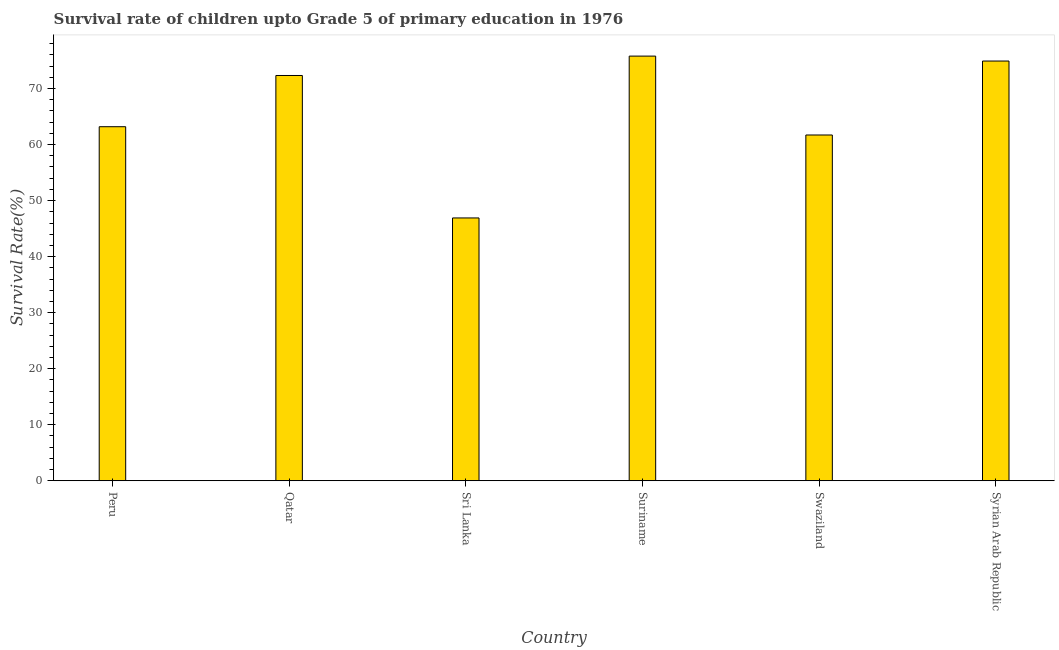Does the graph contain any zero values?
Offer a very short reply. No. Does the graph contain grids?
Give a very brief answer. No. What is the title of the graph?
Provide a succinct answer. Survival rate of children upto Grade 5 of primary education in 1976 . What is the label or title of the Y-axis?
Give a very brief answer. Survival Rate(%). What is the survival rate in Qatar?
Give a very brief answer. 72.33. Across all countries, what is the maximum survival rate?
Make the answer very short. 75.79. Across all countries, what is the minimum survival rate?
Offer a very short reply. 46.91. In which country was the survival rate maximum?
Make the answer very short. Suriname. In which country was the survival rate minimum?
Make the answer very short. Sri Lanka. What is the sum of the survival rate?
Give a very brief answer. 394.84. What is the difference between the survival rate in Qatar and Suriname?
Keep it short and to the point. -3.46. What is the average survival rate per country?
Provide a short and direct response. 65.81. What is the median survival rate?
Your answer should be compact. 67.76. In how many countries, is the survival rate greater than 18 %?
Offer a terse response. 6. What is the ratio of the survival rate in Qatar to that in Suriname?
Provide a succinct answer. 0.95. Is the difference between the survival rate in Sri Lanka and Swaziland greater than the difference between any two countries?
Offer a terse response. No. What is the difference between the highest and the second highest survival rate?
Offer a terse response. 0.88. Is the sum of the survival rate in Sri Lanka and Swaziland greater than the maximum survival rate across all countries?
Make the answer very short. Yes. What is the difference between the highest and the lowest survival rate?
Your response must be concise. 28.88. In how many countries, is the survival rate greater than the average survival rate taken over all countries?
Ensure brevity in your answer.  3. Are all the bars in the graph horizontal?
Provide a succinct answer. No. What is the Survival Rate(%) of Peru?
Offer a terse response. 63.19. What is the Survival Rate(%) of Qatar?
Ensure brevity in your answer.  72.33. What is the Survival Rate(%) of Sri Lanka?
Your answer should be compact. 46.91. What is the Survival Rate(%) of Suriname?
Your answer should be compact. 75.79. What is the Survival Rate(%) of Swaziland?
Keep it short and to the point. 61.71. What is the Survival Rate(%) of Syrian Arab Republic?
Offer a terse response. 74.91. What is the difference between the Survival Rate(%) in Peru and Qatar?
Make the answer very short. -9.14. What is the difference between the Survival Rate(%) in Peru and Sri Lanka?
Provide a short and direct response. 16.28. What is the difference between the Survival Rate(%) in Peru and Suriname?
Your response must be concise. -12.6. What is the difference between the Survival Rate(%) in Peru and Swaziland?
Your answer should be compact. 1.48. What is the difference between the Survival Rate(%) in Peru and Syrian Arab Republic?
Provide a succinct answer. -11.72. What is the difference between the Survival Rate(%) in Qatar and Sri Lanka?
Your answer should be very brief. 25.42. What is the difference between the Survival Rate(%) in Qatar and Suriname?
Ensure brevity in your answer.  -3.46. What is the difference between the Survival Rate(%) in Qatar and Swaziland?
Ensure brevity in your answer.  10.62. What is the difference between the Survival Rate(%) in Qatar and Syrian Arab Republic?
Ensure brevity in your answer.  -2.58. What is the difference between the Survival Rate(%) in Sri Lanka and Suriname?
Offer a terse response. -28.88. What is the difference between the Survival Rate(%) in Sri Lanka and Swaziland?
Provide a succinct answer. -14.81. What is the difference between the Survival Rate(%) in Sri Lanka and Syrian Arab Republic?
Offer a terse response. -28. What is the difference between the Survival Rate(%) in Suriname and Swaziland?
Provide a short and direct response. 14.08. What is the difference between the Survival Rate(%) in Suriname and Syrian Arab Republic?
Keep it short and to the point. 0.88. What is the difference between the Survival Rate(%) in Swaziland and Syrian Arab Republic?
Keep it short and to the point. -13.2. What is the ratio of the Survival Rate(%) in Peru to that in Qatar?
Your response must be concise. 0.87. What is the ratio of the Survival Rate(%) in Peru to that in Sri Lanka?
Provide a succinct answer. 1.35. What is the ratio of the Survival Rate(%) in Peru to that in Suriname?
Give a very brief answer. 0.83. What is the ratio of the Survival Rate(%) in Peru to that in Syrian Arab Republic?
Provide a short and direct response. 0.84. What is the ratio of the Survival Rate(%) in Qatar to that in Sri Lanka?
Provide a short and direct response. 1.54. What is the ratio of the Survival Rate(%) in Qatar to that in Suriname?
Offer a very short reply. 0.95. What is the ratio of the Survival Rate(%) in Qatar to that in Swaziland?
Ensure brevity in your answer.  1.17. What is the ratio of the Survival Rate(%) in Sri Lanka to that in Suriname?
Your answer should be very brief. 0.62. What is the ratio of the Survival Rate(%) in Sri Lanka to that in Swaziland?
Your answer should be compact. 0.76. What is the ratio of the Survival Rate(%) in Sri Lanka to that in Syrian Arab Republic?
Your answer should be compact. 0.63. What is the ratio of the Survival Rate(%) in Suriname to that in Swaziland?
Provide a short and direct response. 1.23. What is the ratio of the Survival Rate(%) in Suriname to that in Syrian Arab Republic?
Your response must be concise. 1.01. What is the ratio of the Survival Rate(%) in Swaziland to that in Syrian Arab Republic?
Your answer should be compact. 0.82. 